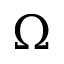Convert formula to latex. <formula><loc_0><loc_0><loc_500><loc_500>\Omega</formula> 